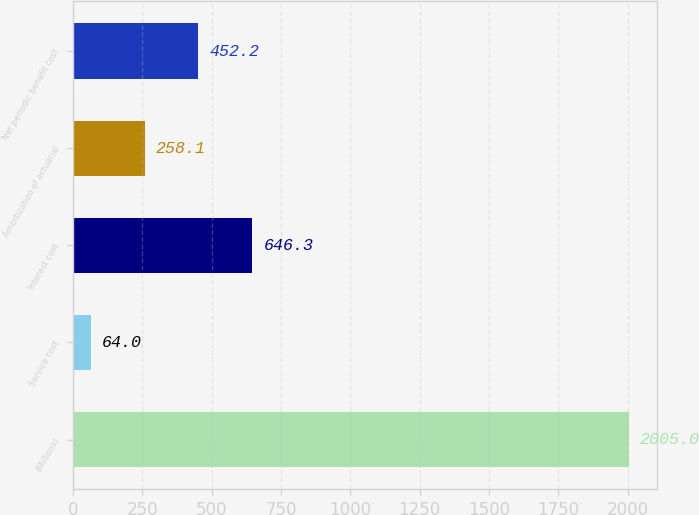Convert chart to OTSL. <chart><loc_0><loc_0><loc_500><loc_500><bar_chart><fcel>(Millions)<fcel>Service cost<fcel>Interest cost<fcel>Amortization of actuarial<fcel>Net periodic benefit cost<nl><fcel>2005<fcel>64<fcel>646.3<fcel>258.1<fcel>452.2<nl></chart> 